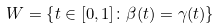<formula> <loc_0><loc_0><loc_500><loc_500>W = \left \{ t \in [ 0 , 1 ] \colon \beta ( t ) = \gamma ( t ) \right \}</formula> 